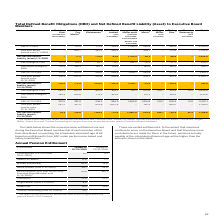According to Sap Ag's financial document, What do the rights for Bill McDermott refer to?  refer solely to rights under the pension plan for SAP America.. The document states: "1) The rights shown here for Bill McDermott refer solely to rights under the pension plan for SAP America...." Also, What kind of entitlements are annual pension entitlements as displayed in the table? According to the financial document, vested entitlements. The relevant text states: "These are vested entitlements. To the extent that members..." Also, In which years are the annual pension entitlements vested? The document shows two values: 2019 and 2018. From the document: "10/10/2019) 1) DBO 1/1/2018 – 93.5 271.9 584.5 1,310.5 585.9 – 344.6 – 3,190.9..." Additionally, In which year was the amount vested for Michael Kleinemeier larger? According to the financial document, 2019. The relevant text states: "10/10/2019) 1)..." Also, can you calculate: What was the change in the amount for Christian Klein in 2019 from 2018? Based on the calculation: 8.2-4.1, the result is 4.1 (in thousands). This is based on the information: "8.2 4.1 8.2 4.1..." The key data points involved are: 8.2. Also, can you calculate: What was the percentage change in the amount for Christian Klein in 2019 from 2018? To answer this question, I need to perform calculations using the financial data. The calculation is: (8.2-4.1)/4.1, which equals 100 (percentage). This is based on the information: "8.2 4.1 8.2 4.1..." The key data points involved are: 4.1, 8.2. 